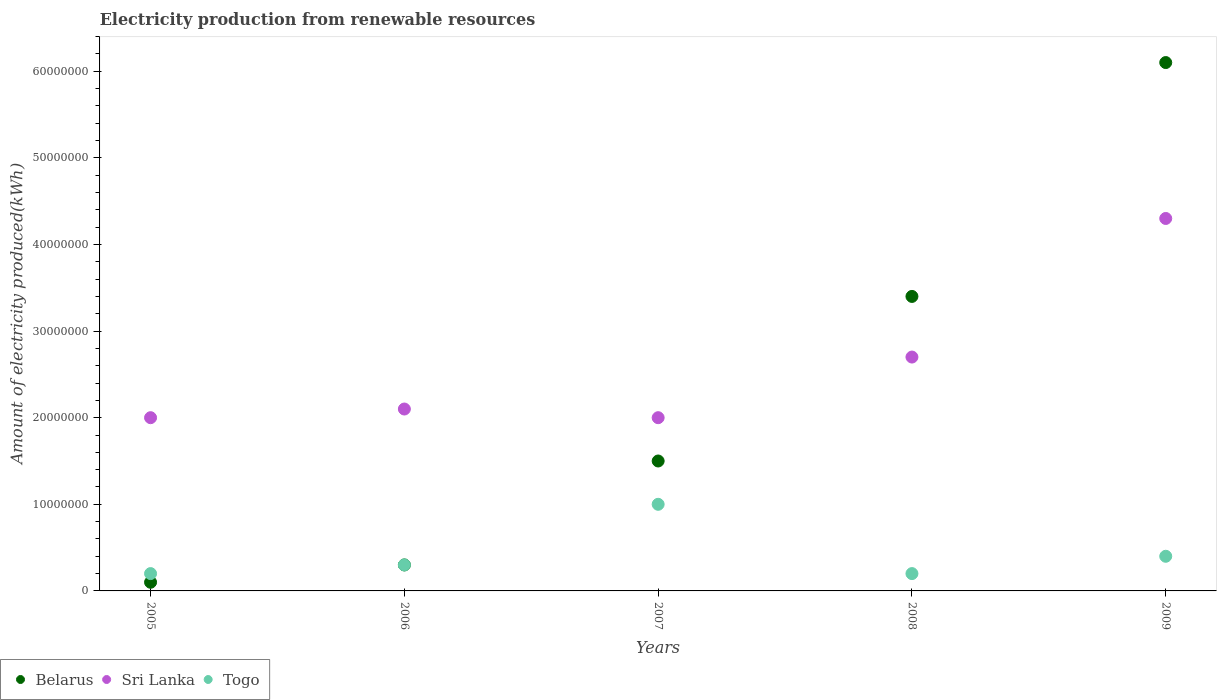How many different coloured dotlines are there?
Offer a very short reply. 3. What is the amount of electricity produced in Togo in 2006?
Provide a succinct answer. 3.00e+06. Across all years, what is the maximum amount of electricity produced in Sri Lanka?
Your answer should be compact. 4.30e+07. In which year was the amount of electricity produced in Togo maximum?
Provide a succinct answer. 2007. In which year was the amount of electricity produced in Belarus minimum?
Your answer should be compact. 2005. What is the total amount of electricity produced in Belarus in the graph?
Offer a very short reply. 1.14e+08. What is the difference between the amount of electricity produced in Sri Lanka in 2005 and that in 2008?
Make the answer very short. -7.00e+06. What is the difference between the amount of electricity produced in Belarus in 2007 and the amount of electricity produced in Togo in 2009?
Provide a succinct answer. 1.10e+07. What is the average amount of electricity produced in Sri Lanka per year?
Offer a very short reply. 2.62e+07. In the year 2005, what is the difference between the amount of electricity produced in Togo and amount of electricity produced in Sri Lanka?
Provide a succinct answer. -1.80e+07. In how many years, is the amount of electricity produced in Sri Lanka greater than 40000000 kWh?
Ensure brevity in your answer.  1. What is the ratio of the amount of electricity produced in Togo in 2005 to that in 2006?
Make the answer very short. 0.67. Is the amount of electricity produced in Belarus in 2007 less than that in 2008?
Make the answer very short. Yes. Is the difference between the amount of electricity produced in Togo in 2006 and 2007 greater than the difference between the amount of electricity produced in Sri Lanka in 2006 and 2007?
Give a very brief answer. No. What is the difference between the highest and the second highest amount of electricity produced in Togo?
Provide a succinct answer. 6.00e+06. What is the difference between the highest and the lowest amount of electricity produced in Sri Lanka?
Make the answer very short. 2.30e+07. Is the sum of the amount of electricity produced in Belarus in 2007 and 2009 greater than the maximum amount of electricity produced in Sri Lanka across all years?
Give a very brief answer. Yes. Is it the case that in every year, the sum of the amount of electricity produced in Belarus and amount of electricity produced in Sri Lanka  is greater than the amount of electricity produced in Togo?
Provide a succinct answer. Yes. Does the amount of electricity produced in Sri Lanka monotonically increase over the years?
Offer a very short reply. No. Is the amount of electricity produced in Belarus strictly less than the amount of electricity produced in Togo over the years?
Offer a very short reply. No. How many dotlines are there?
Ensure brevity in your answer.  3. How many years are there in the graph?
Ensure brevity in your answer.  5. Does the graph contain grids?
Give a very brief answer. No. How are the legend labels stacked?
Ensure brevity in your answer.  Horizontal. What is the title of the graph?
Provide a short and direct response. Electricity production from renewable resources. What is the label or title of the X-axis?
Offer a very short reply. Years. What is the label or title of the Y-axis?
Offer a terse response. Amount of electricity produced(kWh). What is the Amount of electricity produced(kWh) of Sri Lanka in 2005?
Provide a succinct answer. 2.00e+07. What is the Amount of electricity produced(kWh) of Sri Lanka in 2006?
Make the answer very short. 2.10e+07. What is the Amount of electricity produced(kWh) of Togo in 2006?
Your response must be concise. 3.00e+06. What is the Amount of electricity produced(kWh) in Belarus in 2007?
Your answer should be very brief. 1.50e+07. What is the Amount of electricity produced(kWh) in Belarus in 2008?
Offer a terse response. 3.40e+07. What is the Amount of electricity produced(kWh) in Sri Lanka in 2008?
Provide a succinct answer. 2.70e+07. What is the Amount of electricity produced(kWh) of Togo in 2008?
Provide a succinct answer. 2.00e+06. What is the Amount of electricity produced(kWh) in Belarus in 2009?
Provide a short and direct response. 6.10e+07. What is the Amount of electricity produced(kWh) of Sri Lanka in 2009?
Your answer should be compact. 4.30e+07. Across all years, what is the maximum Amount of electricity produced(kWh) of Belarus?
Keep it short and to the point. 6.10e+07. Across all years, what is the maximum Amount of electricity produced(kWh) of Sri Lanka?
Offer a very short reply. 4.30e+07. Across all years, what is the maximum Amount of electricity produced(kWh) of Togo?
Offer a very short reply. 1.00e+07. What is the total Amount of electricity produced(kWh) of Belarus in the graph?
Offer a very short reply. 1.14e+08. What is the total Amount of electricity produced(kWh) of Sri Lanka in the graph?
Provide a short and direct response. 1.31e+08. What is the total Amount of electricity produced(kWh) of Togo in the graph?
Offer a very short reply. 2.10e+07. What is the difference between the Amount of electricity produced(kWh) in Belarus in 2005 and that in 2007?
Give a very brief answer. -1.40e+07. What is the difference between the Amount of electricity produced(kWh) in Togo in 2005 and that in 2007?
Provide a succinct answer. -8.00e+06. What is the difference between the Amount of electricity produced(kWh) in Belarus in 2005 and that in 2008?
Ensure brevity in your answer.  -3.30e+07. What is the difference between the Amount of electricity produced(kWh) in Sri Lanka in 2005 and that in 2008?
Keep it short and to the point. -7.00e+06. What is the difference between the Amount of electricity produced(kWh) of Belarus in 2005 and that in 2009?
Give a very brief answer. -6.00e+07. What is the difference between the Amount of electricity produced(kWh) in Sri Lanka in 2005 and that in 2009?
Keep it short and to the point. -2.30e+07. What is the difference between the Amount of electricity produced(kWh) in Togo in 2005 and that in 2009?
Ensure brevity in your answer.  -2.00e+06. What is the difference between the Amount of electricity produced(kWh) of Belarus in 2006 and that in 2007?
Offer a terse response. -1.20e+07. What is the difference between the Amount of electricity produced(kWh) of Togo in 2006 and that in 2007?
Offer a terse response. -7.00e+06. What is the difference between the Amount of electricity produced(kWh) in Belarus in 2006 and that in 2008?
Provide a short and direct response. -3.10e+07. What is the difference between the Amount of electricity produced(kWh) of Sri Lanka in 2006 and that in 2008?
Make the answer very short. -6.00e+06. What is the difference between the Amount of electricity produced(kWh) in Togo in 2006 and that in 2008?
Keep it short and to the point. 1.00e+06. What is the difference between the Amount of electricity produced(kWh) in Belarus in 2006 and that in 2009?
Offer a terse response. -5.80e+07. What is the difference between the Amount of electricity produced(kWh) in Sri Lanka in 2006 and that in 2009?
Your answer should be very brief. -2.20e+07. What is the difference between the Amount of electricity produced(kWh) of Togo in 2006 and that in 2009?
Provide a succinct answer. -1.00e+06. What is the difference between the Amount of electricity produced(kWh) in Belarus in 2007 and that in 2008?
Ensure brevity in your answer.  -1.90e+07. What is the difference between the Amount of electricity produced(kWh) in Sri Lanka in 2007 and that in 2008?
Offer a very short reply. -7.00e+06. What is the difference between the Amount of electricity produced(kWh) of Belarus in 2007 and that in 2009?
Ensure brevity in your answer.  -4.60e+07. What is the difference between the Amount of electricity produced(kWh) of Sri Lanka in 2007 and that in 2009?
Give a very brief answer. -2.30e+07. What is the difference between the Amount of electricity produced(kWh) of Belarus in 2008 and that in 2009?
Provide a short and direct response. -2.70e+07. What is the difference between the Amount of electricity produced(kWh) of Sri Lanka in 2008 and that in 2009?
Your answer should be compact. -1.60e+07. What is the difference between the Amount of electricity produced(kWh) in Belarus in 2005 and the Amount of electricity produced(kWh) in Sri Lanka in 2006?
Ensure brevity in your answer.  -2.00e+07. What is the difference between the Amount of electricity produced(kWh) in Sri Lanka in 2005 and the Amount of electricity produced(kWh) in Togo in 2006?
Provide a succinct answer. 1.70e+07. What is the difference between the Amount of electricity produced(kWh) of Belarus in 2005 and the Amount of electricity produced(kWh) of Sri Lanka in 2007?
Offer a very short reply. -1.90e+07. What is the difference between the Amount of electricity produced(kWh) of Belarus in 2005 and the Amount of electricity produced(kWh) of Togo in 2007?
Provide a succinct answer. -9.00e+06. What is the difference between the Amount of electricity produced(kWh) in Belarus in 2005 and the Amount of electricity produced(kWh) in Sri Lanka in 2008?
Keep it short and to the point. -2.60e+07. What is the difference between the Amount of electricity produced(kWh) in Sri Lanka in 2005 and the Amount of electricity produced(kWh) in Togo in 2008?
Your answer should be very brief. 1.80e+07. What is the difference between the Amount of electricity produced(kWh) in Belarus in 2005 and the Amount of electricity produced(kWh) in Sri Lanka in 2009?
Offer a very short reply. -4.20e+07. What is the difference between the Amount of electricity produced(kWh) of Belarus in 2005 and the Amount of electricity produced(kWh) of Togo in 2009?
Your answer should be compact. -3.00e+06. What is the difference between the Amount of electricity produced(kWh) in Sri Lanka in 2005 and the Amount of electricity produced(kWh) in Togo in 2009?
Give a very brief answer. 1.60e+07. What is the difference between the Amount of electricity produced(kWh) in Belarus in 2006 and the Amount of electricity produced(kWh) in Sri Lanka in 2007?
Offer a terse response. -1.70e+07. What is the difference between the Amount of electricity produced(kWh) in Belarus in 2006 and the Amount of electricity produced(kWh) in Togo in 2007?
Your answer should be compact. -7.00e+06. What is the difference between the Amount of electricity produced(kWh) of Sri Lanka in 2006 and the Amount of electricity produced(kWh) of Togo in 2007?
Ensure brevity in your answer.  1.10e+07. What is the difference between the Amount of electricity produced(kWh) in Belarus in 2006 and the Amount of electricity produced(kWh) in Sri Lanka in 2008?
Give a very brief answer. -2.40e+07. What is the difference between the Amount of electricity produced(kWh) of Sri Lanka in 2006 and the Amount of electricity produced(kWh) of Togo in 2008?
Offer a very short reply. 1.90e+07. What is the difference between the Amount of electricity produced(kWh) in Belarus in 2006 and the Amount of electricity produced(kWh) in Sri Lanka in 2009?
Your answer should be very brief. -4.00e+07. What is the difference between the Amount of electricity produced(kWh) of Belarus in 2006 and the Amount of electricity produced(kWh) of Togo in 2009?
Offer a terse response. -1.00e+06. What is the difference between the Amount of electricity produced(kWh) in Sri Lanka in 2006 and the Amount of electricity produced(kWh) in Togo in 2009?
Offer a very short reply. 1.70e+07. What is the difference between the Amount of electricity produced(kWh) of Belarus in 2007 and the Amount of electricity produced(kWh) of Sri Lanka in 2008?
Make the answer very short. -1.20e+07. What is the difference between the Amount of electricity produced(kWh) of Belarus in 2007 and the Amount of electricity produced(kWh) of Togo in 2008?
Provide a succinct answer. 1.30e+07. What is the difference between the Amount of electricity produced(kWh) of Sri Lanka in 2007 and the Amount of electricity produced(kWh) of Togo in 2008?
Your answer should be very brief. 1.80e+07. What is the difference between the Amount of electricity produced(kWh) of Belarus in 2007 and the Amount of electricity produced(kWh) of Sri Lanka in 2009?
Provide a succinct answer. -2.80e+07. What is the difference between the Amount of electricity produced(kWh) of Belarus in 2007 and the Amount of electricity produced(kWh) of Togo in 2009?
Your response must be concise. 1.10e+07. What is the difference between the Amount of electricity produced(kWh) of Sri Lanka in 2007 and the Amount of electricity produced(kWh) of Togo in 2009?
Your answer should be compact. 1.60e+07. What is the difference between the Amount of electricity produced(kWh) in Belarus in 2008 and the Amount of electricity produced(kWh) in Sri Lanka in 2009?
Offer a very short reply. -9.00e+06. What is the difference between the Amount of electricity produced(kWh) in Belarus in 2008 and the Amount of electricity produced(kWh) in Togo in 2009?
Provide a succinct answer. 3.00e+07. What is the difference between the Amount of electricity produced(kWh) in Sri Lanka in 2008 and the Amount of electricity produced(kWh) in Togo in 2009?
Offer a very short reply. 2.30e+07. What is the average Amount of electricity produced(kWh) of Belarus per year?
Offer a terse response. 2.28e+07. What is the average Amount of electricity produced(kWh) of Sri Lanka per year?
Offer a terse response. 2.62e+07. What is the average Amount of electricity produced(kWh) of Togo per year?
Your answer should be very brief. 4.20e+06. In the year 2005, what is the difference between the Amount of electricity produced(kWh) in Belarus and Amount of electricity produced(kWh) in Sri Lanka?
Ensure brevity in your answer.  -1.90e+07. In the year 2005, what is the difference between the Amount of electricity produced(kWh) in Sri Lanka and Amount of electricity produced(kWh) in Togo?
Your answer should be very brief. 1.80e+07. In the year 2006, what is the difference between the Amount of electricity produced(kWh) of Belarus and Amount of electricity produced(kWh) of Sri Lanka?
Your answer should be compact. -1.80e+07. In the year 2006, what is the difference between the Amount of electricity produced(kWh) of Sri Lanka and Amount of electricity produced(kWh) of Togo?
Provide a succinct answer. 1.80e+07. In the year 2007, what is the difference between the Amount of electricity produced(kWh) of Belarus and Amount of electricity produced(kWh) of Sri Lanka?
Provide a short and direct response. -5.00e+06. In the year 2007, what is the difference between the Amount of electricity produced(kWh) in Belarus and Amount of electricity produced(kWh) in Togo?
Make the answer very short. 5.00e+06. In the year 2008, what is the difference between the Amount of electricity produced(kWh) in Belarus and Amount of electricity produced(kWh) in Sri Lanka?
Offer a very short reply. 7.00e+06. In the year 2008, what is the difference between the Amount of electricity produced(kWh) in Belarus and Amount of electricity produced(kWh) in Togo?
Offer a very short reply. 3.20e+07. In the year 2008, what is the difference between the Amount of electricity produced(kWh) of Sri Lanka and Amount of electricity produced(kWh) of Togo?
Provide a short and direct response. 2.50e+07. In the year 2009, what is the difference between the Amount of electricity produced(kWh) in Belarus and Amount of electricity produced(kWh) in Sri Lanka?
Provide a succinct answer. 1.80e+07. In the year 2009, what is the difference between the Amount of electricity produced(kWh) in Belarus and Amount of electricity produced(kWh) in Togo?
Keep it short and to the point. 5.70e+07. In the year 2009, what is the difference between the Amount of electricity produced(kWh) of Sri Lanka and Amount of electricity produced(kWh) of Togo?
Ensure brevity in your answer.  3.90e+07. What is the ratio of the Amount of electricity produced(kWh) in Togo in 2005 to that in 2006?
Offer a very short reply. 0.67. What is the ratio of the Amount of electricity produced(kWh) of Belarus in 2005 to that in 2007?
Offer a very short reply. 0.07. What is the ratio of the Amount of electricity produced(kWh) of Togo in 2005 to that in 2007?
Keep it short and to the point. 0.2. What is the ratio of the Amount of electricity produced(kWh) of Belarus in 2005 to that in 2008?
Provide a succinct answer. 0.03. What is the ratio of the Amount of electricity produced(kWh) in Sri Lanka in 2005 to that in 2008?
Your answer should be compact. 0.74. What is the ratio of the Amount of electricity produced(kWh) of Togo in 2005 to that in 2008?
Your answer should be compact. 1. What is the ratio of the Amount of electricity produced(kWh) in Belarus in 2005 to that in 2009?
Ensure brevity in your answer.  0.02. What is the ratio of the Amount of electricity produced(kWh) of Sri Lanka in 2005 to that in 2009?
Offer a very short reply. 0.47. What is the ratio of the Amount of electricity produced(kWh) of Belarus in 2006 to that in 2007?
Make the answer very short. 0.2. What is the ratio of the Amount of electricity produced(kWh) of Sri Lanka in 2006 to that in 2007?
Your answer should be compact. 1.05. What is the ratio of the Amount of electricity produced(kWh) of Belarus in 2006 to that in 2008?
Your response must be concise. 0.09. What is the ratio of the Amount of electricity produced(kWh) in Belarus in 2006 to that in 2009?
Give a very brief answer. 0.05. What is the ratio of the Amount of electricity produced(kWh) of Sri Lanka in 2006 to that in 2009?
Offer a very short reply. 0.49. What is the ratio of the Amount of electricity produced(kWh) in Belarus in 2007 to that in 2008?
Make the answer very short. 0.44. What is the ratio of the Amount of electricity produced(kWh) in Sri Lanka in 2007 to that in 2008?
Ensure brevity in your answer.  0.74. What is the ratio of the Amount of electricity produced(kWh) of Belarus in 2007 to that in 2009?
Your response must be concise. 0.25. What is the ratio of the Amount of electricity produced(kWh) of Sri Lanka in 2007 to that in 2009?
Ensure brevity in your answer.  0.47. What is the ratio of the Amount of electricity produced(kWh) in Togo in 2007 to that in 2009?
Make the answer very short. 2.5. What is the ratio of the Amount of electricity produced(kWh) in Belarus in 2008 to that in 2009?
Your response must be concise. 0.56. What is the ratio of the Amount of electricity produced(kWh) of Sri Lanka in 2008 to that in 2009?
Offer a terse response. 0.63. What is the difference between the highest and the second highest Amount of electricity produced(kWh) in Belarus?
Keep it short and to the point. 2.70e+07. What is the difference between the highest and the second highest Amount of electricity produced(kWh) in Sri Lanka?
Give a very brief answer. 1.60e+07. What is the difference between the highest and the second highest Amount of electricity produced(kWh) of Togo?
Make the answer very short. 6.00e+06. What is the difference between the highest and the lowest Amount of electricity produced(kWh) of Belarus?
Provide a succinct answer. 6.00e+07. What is the difference between the highest and the lowest Amount of electricity produced(kWh) of Sri Lanka?
Your response must be concise. 2.30e+07. 